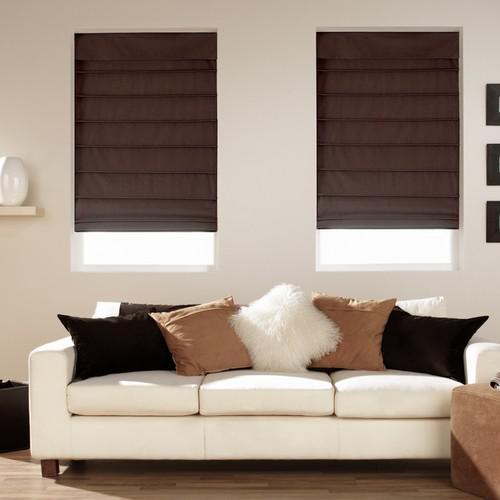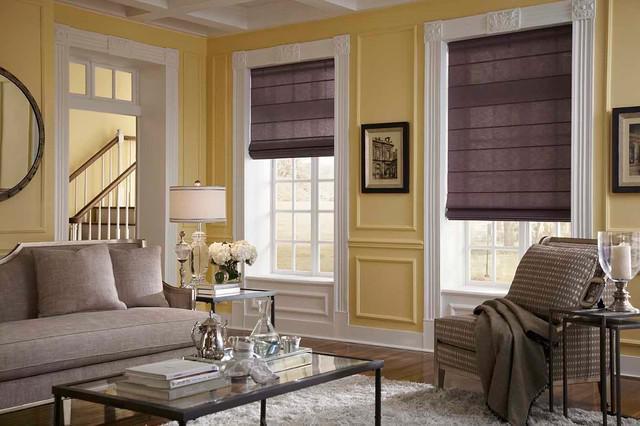The first image is the image on the left, the second image is the image on the right. Evaluate the accuracy of this statement regarding the images: "A white couch in one image is in front of two windows with the shades lowered to equal lengths.". Is it true? Answer yes or no. Yes. The first image is the image on the left, the second image is the image on the right. Evaluate the accuracy of this statement regarding the images: "All the window shades are partially up.". Is it true? Answer yes or no. Yes. 